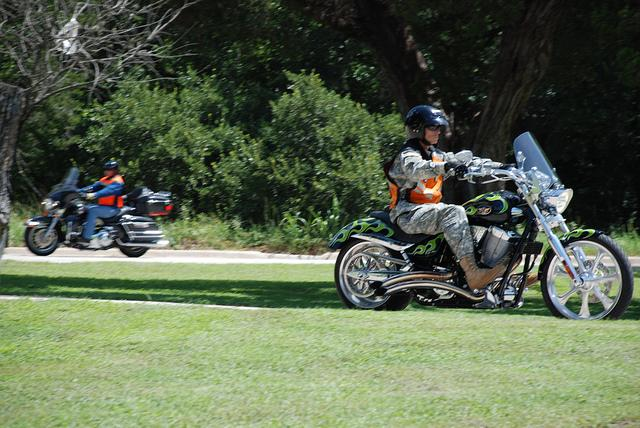The man riding the motorcycle is involved in what type of public service? Please explain your reasoning. military. The man is in the military since he's wearing cameo. 